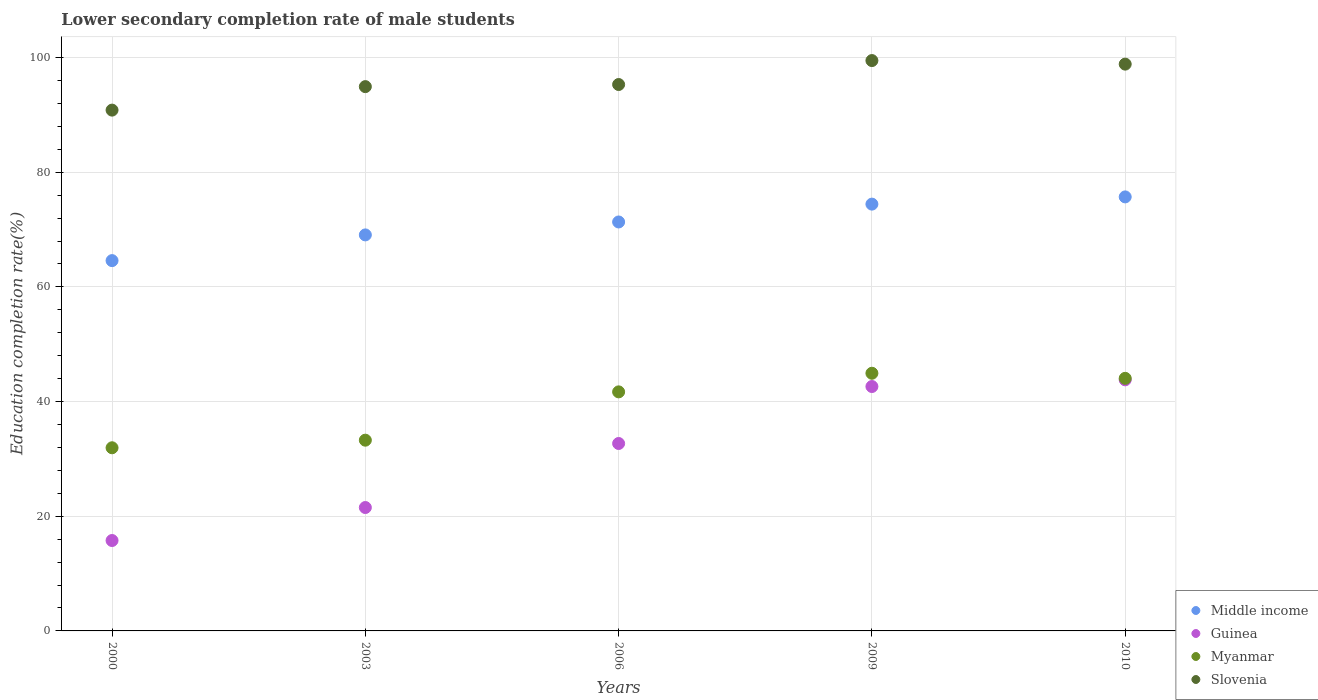What is the lower secondary completion rate of male students in Guinea in 2009?
Give a very brief answer. 42.62. Across all years, what is the maximum lower secondary completion rate of male students in Slovenia?
Offer a very short reply. 99.47. Across all years, what is the minimum lower secondary completion rate of male students in Myanmar?
Your answer should be very brief. 31.94. What is the total lower secondary completion rate of male students in Slovenia in the graph?
Give a very brief answer. 479.35. What is the difference between the lower secondary completion rate of male students in Middle income in 2003 and that in 2010?
Your answer should be very brief. -6.63. What is the difference between the lower secondary completion rate of male students in Slovenia in 2003 and the lower secondary completion rate of male students in Myanmar in 2000?
Your answer should be compact. 62.98. What is the average lower secondary completion rate of male students in Middle income per year?
Ensure brevity in your answer.  71.02. In the year 2000, what is the difference between the lower secondary completion rate of male students in Guinea and lower secondary completion rate of male students in Middle income?
Give a very brief answer. -48.81. In how many years, is the lower secondary completion rate of male students in Guinea greater than 44 %?
Your answer should be compact. 0. What is the ratio of the lower secondary completion rate of male students in Middle income in 2003 to that in 2009?
Ensure brevity in your answer.  0.93. Is the difference between the lower secondary completion rate of male students in Guinea in 2006 and 2009 greater than the difference between the lower secondary completion rate of male students in Middle income in 2006 and 2009?
Your response must be concise. No. What is the difference between the highest and the second highest lower secondary completion rate of male students in Middle income?
Provide a succinct answer. 1.26. What is the difference between the highest and the lowest lower secondary completion rate of male students in Middle income?
Your response must be concise. 11.11. In how many years, is the lower secondary completion rate of male students in Middle income greater than the average lower secondary completion rate of male students in Middle income taken over all years?
Provide a succinct answer. 3. Is the lower secondary completion rate of male students in Guinea strictly greater than the lower secondary completion rate of male students in Myanmar over the years?
Offer a very short reply. No. What is the difference between two consecutive major ticks on the Y-axis?
Keep it short and to the point. 20. Are the values on the major ticks of Y-axis written in scientific E-notation?
Make the answer very short. No. Where does the legend appear in the graph?
Ensure brevity in your answer.  Bottom right. How many legend labels are there?
Provide a short and direct response. 4. What is the title of the graph?
Your answer should be compact. Lower secondary completion rate of male students. Does "Isle of Man" appear as one of the legend labels in the graph?
Your response must be concise. No. What is the label or title of the Y-axis?
Provide a succinct answer. Education completion rate(%). What is the Education completion rate(%) of Middle income in 2000?
Keep it short and to the point. 64.58. What is the Education completion rate(%) of Guinea in 2000?
Your answer should be compact. 15.77. What is the Education completion rate(%) in Myanmar in 2000?
Keep it short and to the point. 31.94. What is the Education completion rate(%) of Slovenia in 2000?
Provide a succinct answer. 90.83. What is the Education completion rate(%) in Middle income in 2003?
Ensure brevity in your answer.  69.06. What is the Education completion rate(%) in Guinea in 2003?
Offer a very short reply. 21.52. What is the Education completion rate(%) of Myanmar in 2003?
Offer a very short reply. 33.26. What is the Education completion rate(%) of Slovenia in 2003?
Provide a succinct answer. 94.92. What is the Education completion rate(%) of Middle income in 2006?
Keep it short and to the point. 71.32. What is the Education completion rate(%) of Guinea in 2006?
Give a very brief answer. 32.69. What is the Education completion rate(%) in Myanmar in 2006?
Offer a terse response. 41.69. What is the Education completion rate(%) in Slovenia in 2006?
Offer a terse response. 95.29. What is the Education completion rate(%) in Middle income in 2009?
Your response must be concise. 74.43. What is the Education completion rate(%) of Guinea in 2009?
Your answer should be compact. 42.62. What is the Education completion rate(%) of Myanmar in 2009?
Offer a terse response. 44.94. What is the Education completion rate(%) in Slovenia in 2009?
Your answer should be very brief. 99.47. What is the Education completion rate(%) of Middle income in 2010?
Your response must be concise. 75.69. What is the Education completion rate(%) in Guinea in 2010?
Offer a very short reply. 43.79. What is the Education completion rate(%) of Myanmar in 2010?
Keep it short and to the point. 44.05. What is the Education completion rate(%) of Slovenia in 2010?
Your response must be concise. 98.85. Across all years, what is the maximum Education completion rate(%) of Middle income?
Give a very brief answer. 75.69. Across all years, what is the maximum Education completion rate(%) in Guinea?
Your response must be concise. 43.79. Across all years, what is the maximum Education completion rate(%) of Myanmar?
Ensure brevity in your answer.  44.94. Across all years, what is the maximum Education completion rate(%) of Slovenia?
Your answer should be very brief. 99.47. Across all years, what is the minimum Education completion rate(%) of Middle income?
Offer a terse response. 64.58. Across all years, what is the minimum Education completion rate(%) in Guinea?
Keep it short and to the point. 15.77. Across all years, what is the minimum Education completion rate(%) in Myanmar?
Provide a succinct answer. 31.94. Across all years, what is the minimum Education completion rate(%) of Slovenia?
Your response must be concise. 90.83. What is the total Education completion rate(%) of Middle income in the graph?
Ensure brevity in your answer.  355.09. What is the total Education completion rate(%) in Guinea in the graph?
Your answer should be compact. 156.38. What is the total Education completion rate(%) in Myanmar in the graph?
Provide a succinct answer. 195.88. What is the total Education completion rate(%) in Slovenia in the graph?
Offer a terse response. 479.35. What is the difference between the Education completion rate(%) of Middle income in 2000 and that in 2003?
Provide a succinct answer. -4.48. What is the difference between the Education completion rate(%) in Guinea in 2000 and that in 2003?
Ensure brevity in your answer.  -5.75. What is the difference between the Education completion rate(%) of Myanmar in 2000 and that in 2003?
Make the answer very short. -1.32. What is the difference between the Education completion rate(%) of Slovenia in 2000 and that in 2003?
Your answer should be very brief. -4.1. What is the difference between the Education completion rate(%) in Middle income in 2000 and that in 2006?
Ensure brevity in your answer.  -6.74. What is the difference between the Education completion rate(%) in Guinea in 2000 and that in 2006?
Your answer should be very brief. -16.92. What is the difference between the Education completion rate(%) in Myanmar in 2000 and that in 2006?
Give a very brief answer. -9.75. What is the difference between the Education completion rate(%) of Slovenia in 2000 and that in 2006?
Your response must be concise. -4.46. What is the difference between the Education completion rate(%) in Middle income in 2000 and that in 2009?
Provide a short and direct response. -9.85. What is the difference between the Education completion rate(%) of Guinea in 2000 and that in 2009?
Your answer should be compact. -26.86. What is the difference between the Education completion rate(%) of Myanmar in 2000 and that in 2009?
Make the answer very short. -13. What is the difference between the Education completion rate(%) in Slovenia in 2000 and that in 2009?
Provide a short and direct response. -8.64. What is the difference between the Education completion rate(%) in Middle income in 2000 and that in 2010?
Provide a succinct answer. -11.11. What is the difference between the Education completion rate(%) in Guinea in 2000 and that in 2010?
Offer a terse response. -28.02. What is the difference between the Education completion rate(%) in Myanmar in 2000 and that in 2010?
Keep it short and to the point. -12.11. What is the difference between the Education completion rate(%) in Slovenia in 2000 and that in 2010?
Make the answer very short. -8.02. What is the difference between the Education completion rate(%) in Middle income in 2003 and that in 2006?
Provide a succinct answer. -2.26. What is the difference between the Education completion rate(%) in Guinea in 2003 and that in 2006?
Provide a short and direct response. -11.17. What is the difference between the Education completion rate(%) in Myanmar in 2003 and that in 2006?
Your response must be concise. -8.43. What is the difference between the Education completion rate(%) of Slovenia in 2003 and that in 2006?
Keep it short and to the point. -0.37. What is the difference between the Education completion rate(%) of Middle income in 2003 and that in 2009?
Offer a very short reply. -5.37. What is the difference between the Education completion rate(%) of Guinea in 2003 and that in 2009?
Ensure brevity in your answer.  -21.1. What is the difference between the Education completion rate(%) in Myanmar in 2003 and that in 2009?
Ensure brevity in your answer.  -11.67. What is the difference between the Education completion rate(%) of Slovenia in 2003 and that in 2009?
Provide a short and direct response. -4.54. What is the difference between the Education completion rate(%) in Middle income in 2003 and that in 2010?
Offer a terse response. -6.63. What is the difference between the Education completion rate(%) of Guinea in 2003 and that in 2010?
Give a very brief answer. -22.27. What is the difference between the Education completion rate(%) of Myanmar in 2003 and that in 2010?
Your answer should be very brief. -10.79. What is the difference between the Education completion rate(%) of Slovenia in 2003 and that in 2010?
Provide a short and direct response. -3.92. What is the difference between the Education completion rate(%) of Middle income in 2006 and that in 2009?
Your answer should be compact. -3.11. What is the difference between the Education completion rate(%) of Guinea in 2006 and that in 2009?
Your answer should be very brief. -9.94. What is the difference between the Education completion rate(%) in Myanmar in 2006 and that in 2009?
Provide a succinct answer. -3.25. What is the difference between the Education completion rate(%) of Slovenia in 2006 and that in 2009?
Your answer should be very brief. -4.18. What is the difference between the Education completion rate(%) in Middle income in 2006 and that in 2010?
Offer a very short reply. -4.37. What is the difference between the Education completion rate(%) of Guinea in 2006 and that in 2010?
Ensure brevity in your answer.  -11.1. What is the difference between the Education completion rate(%) of Myanmar in 2006 and that in 2010?
Your response must be concise. -2.36. What is the difference between the Education completion rate(%) in Slovenia in 2006 and that in 2010?
Give a very brief answer. -3.56. What is the difference between the Education completion rate(%) in Middle income in 2009 and that in 2010?
Offer a very short reply. -1.26. What is the difference between the Education completion rate(%) in Guinea in 2009 and that in 2010?
Your answer should be very brief. -1.17. What is the difference between the Education completion rate(%) of Myanmar in 2009 and that in 2010?
Provide a succinct answer. 0.89. What is the difference between the Education completion rate(%) of Slovenia in 2009 and that in 2010?
Your response must be concise. 0.62. What is the difference between the Education completion rate(%) of Middle income in 2000 and the Education completion rate(%) of Guinea in 2003?
Ensure brevity in your answer.  43.06. What is the difference between the Education completion rate(%) of Middle income in 2000 and the Education completion rate(%) of Myanmar in 2003?
Your answer should be compact. 31.32. What is the difference between the Education completion rate(%) in Middle income in 2000 and the Education completion rate(%) in Slovenia in 2003?
Offer a very short reply. -30.34. What is the difference between the Education completion rate(%) of Guinea in 2000 and the Education completion rate(%) of Myanmar in 2003?
Your response must be concise. -17.5. What is the difference between the Education completion rate(%) of Guinea in 2000 and the Education completion rate(%) of Slovenia in 2003?
Offer a very short reply. -79.16. What is the difference between the Education completion rate(%) in Myanmar in 2000 and the Education completion rate(%) in Slovenia in 2003?
Your response must be concise. -62.98. What is the difference between the Education completion rate(%) in Middle income in 2000 and the Education completion rate(%) in Guinea in 2006?
Your response must be concise. 31.89. What is the difference between the Education completion rate(%) in Middle income in 2000 and the Education completion rate(%) in Myanmar in 2006?
Your answer should be very brief. 22.89. What is the difference between the Education completion rate(%) of Middle income in 2000 and the Education completion rate(%) of Slovenia in 2006?
Your response must be concise. -30.71. What is the difference between the Education completion rate(%) in Guinea in 2000 and the Education completion rate(%) in Myanmar in 2006?
Make the answer very short. -25.92. What is the difference between the Education completion rate(%) of Guinea in 2000 and the Education completion rate(%) of Slovenia in 2006?
Provide a short and direct response. -79.52. What is the difference between the Education completion rate(%) of Myanmar in 2000 and the Education completion rate(%) of Slovenia in 2006?
Keep it short and to the point. -63.35. What is the difference between the Education completion rate(%) of Middle income in 2000 and the Education completion rate(%) of Guinea in 2009?
Your answer should be very brief. 21.96. What is the difference between the Education completion rate(%) in Middle income in 2000 and the Education completion rate(%) in Myanmar in 2009?
Your answer should be compact. 19.64. What is the difference between the Education completion rate(%) in Middle income in 2000 and the Education completion rate(%) in Slovenia in 2009?
Provide a succinct answer. -34.89. What is the difference between the Education completion rate(%) of Guinea in 2000 and the Education completion rate(%) of Myanmar in 2009?
Provide a short and direct response. -29.17. What is the difference between the Education completion rate(%) in Guinea in 2000 and the Education completion rate(%) in Slovenia in 2009?
Your answer should be very brief. -83.7. What is the difference between the Education completion rate(%) of Myanmar in 2000 and the Education completion rate(%) of Slovenia in 2009?
Provide a succinct answer. -67.53. What is the difference between the Education completion rate(%) of Middle income in 2000 and the Education completion rate(%) of Guinea in 2010?
Make the answer very short. 20.79. What is the difference between the Education completion rate(%) of Middle income in 2000 and the Education completion rate(%) of Myanmar in 2010?
Provide a succinct answer. 20.53. What is the difference between the Education completion rate(%) of Middle income in 2000 and the Education completion rate(%) of Slovenia in 2010?
Offer a very short reply. -34.27. What is the difference between the Education completion rate(%) in Guinea in 2000 and the Education completion rate(%) in Myanmar in 2010?
Provide a short and direct response. -28.28. What is the difference between the Education completion rate(%) in Guinea in 2000 and the Education completion rate(%) in Slovenia in 2010?
Give a very brief answer. -83.08. What is the difference between the Education completion rate(%) in Myanmar in 2000 and the Education completion rate(%) in Slovenia in 2010?
Your answer should be very brief. -66.91. What is the difference between the Education completion rate(%) in Middle income in 2003 and the Education completion rate(%) in Guinea in 2006?
Ensure brevity in your answer.  36.38. What is the difference between the Education completion rate(%) in Middle income in 2003 and the Education completion rate(%) in Myanmar in 2006?
Your response must be concise. 27.37. What is the difference between the Education completion rate(%) in Middle income in 2003 and the Education completion rate(%) in Slovenia in 2006?
Ensure brevity in your answer.  -26.23. What is the difference between the Education completion rate(%) of Guinea in 2003 and the Education completion rate(%) of Myanmar in 2006?
Offer a terse response. -20.17. What is the difference between the Education completion rate(%) of Guinea in 2003 and the Education completion rate(%) of Slovenia in 2006?
Your answer should be compact. -73.77. What is the difference between the Education completion rate(%) in Myanmar in 2003 and the Education completion rate(%) in Slovenia in 2006?
Give a very brief answer. -62.03. What is the difference between the Education completion rate(%) in Middle income in 2003 and the Education completion rate(%) in Guinea in 2009?
Offer a terse response. 26.44. What is the difference between the Education completion rate(%) of Middle income in 2003 and the Education completion rate(%) of Myanmar in 2009?
Keep it short and to the point. 24.13. What is the difference between the Education completion rate(%) in Middle income in 2003 and the Education completion rate(%) in Slovenia in 2009?
Provide a short and direct response. -30.4. What is the difference between the Education completion rate(%) of Guinea in 2003 and the Education completion rate(%) of Myanmar in 2009?
Provide a short and direct response. -23.42. What is the difference between the Education completion rate(%) in Guinea in 2003 and the Education completion rate(%) in Slovenia in 2009?
Keep it short and to the point. -77.95. What is the difference between the Education completion rate(%) in Myanmar in 2003 and the Education completion rate(%) in Slovenia in 2009?
Your answer should be very brief. -66.2. What is the difference between the Education completion rate(%) in Middle income in 2003 and the Education completion rate(%) in Guinea in 2010?
Ensure brevity in your answer.  25.28. What is the difference between the Education completion rate(%) of Middle income in 2003 and the Education completion rate(%) of Myanmar in 2010?
Make the answer very short. 25.01. What is the difference between the Education completion rate(%) of Middle income in 2003 and the Education completion rate(%) of Slovenia in 2010?
Offer a terse response. -29.78. What is the difference between the Education completion rate(%) in Guinea in 2003 and the Education completion rate(%) in Myanmar in 2010?
Your answer should be compact. -22.53. What is the difference between the Education completion rate(%) in Guinea in 2003 and the Education completion rate(%) in Slovenia in 2010?
Offer a very short reply. -77.33. What is the difference between the Education completion rate(%) of Myanmar in 2003 and the Education completion rate(%) of Slovenia in 2010?
Your answer should be compact. -65.58. What is the difference between the Education completion rate(%) in Middle income in 2006 and the Education completion rate(%) in Guinea in 2009?
Keep it short and to the point. 28.7. What is the difference between the Education completion rate(%) in Middle income in 2006 and the Education completion rate(%) in Myanmar in 2009?
Keep it short and to the point. 26.38. What is the difference between the Education completion rate(%) in Middle income in 2006 and the Education completion rate(%) in Slovenia in 2009?
Your answer should be compact. -28.15. What is the difference between the Education completion rate(%) of Guinea in 2006 and the Education completion rate(%) of Myanmar in 2009?
Your answer should be very brief. -12.25. What is the difference between the Education completion rate(%) of Guinea in 2006 and the Education completion rate(%) of Slovenia in 2009?
Offer a very short reply. -66.78. What is the difference between the Education completion rate(%) in Myanmar in 2006 and the Education completion rate(%) in Slovenia in 2009?
Offer a very short reply. -57.78. What is the difference between the Education completion rate(%) of Middle income in 2006 and the Education completion rate(%) of Guinea in 2010?
Provide a succinct answer. 27.53. What is the difference between the Education completion rate(%) of Middle income in 2006 and the Education completion rate(%) of Myanmar in 2010?
Give a very brief answer. 27.27. What is the difference between the Education completion rate(%) of Middle income in 2006 and the Education completion rate(%) of Slovenia in 2010?
Provide a succinct answer. -27.53. What is the difference between the Education completion rate(%) in Guinea in 2006 and the Education completion rate(%) in Myanmar in 2010?
Your answer should be compact. -11.36. What is the difference between the Education completion rate(%) in Guinea in 2006 and the Education completion rate(%) in Slovenia in 2010?
Provide a succinct answer. -66.16. What is the difference between the Education completion rate(%) of Myanmar in 2006 and the Education completion rate(%) of Slovenia in 2010?
Your answer should be compact. -57.16. What is the difference between the Education completion rate(%) of Middle income in 2009 and the Education completion rate(%) of Guinea in 2010?
Offer a terse response. 30.64. What is the difference between the Education completion rate(%) in Middle income in 2009 and the Education completion rate(%) in Myanmar in 2010?
Offer a terse response. 30.38. What is the difference between the Education completion rate(%) in Middle income in 2009 and the Education completion rate(%) in Slovenia in 2010?
Provide a succinct answer. -24.41. What is the difference between the Education completion rate(%) in Guinea in 2009 and the Education completion rate(%) in Myanmar in 2010?
Your answer should be very brief. -1.43. What is the difference between the Education completion rate(%) in Guinea in 2009 and the Education completion rate(%) in Slovenia in 2010?
Keep it short and to the point. -56.22. What is the difference between the Education completion rate(%) in Myanmar in 2009 and the Education completion rate(%) in Slovenia in 2010?
Give a very brief answer. -53.91. What is the average Education completion rate(%) in Middle income per year?
Provide a succinct answer. 71.02. What is the average Education completion rate(%) in Guinea per year?
Give a very brief answer. 31.28. What is the average Education completion rate(%) in Myanmar per year?
Offer a very short reply. 39.18. What is the average Education completion rate(%) in Slovenia per year?
Your response must be concise. 95.87. In the year 2000, what is the difference between the Education completion rate(%) of Middle income and Education completion rate(%) of Guinea?
Make the answer very short. 48.81. In the year 2000, what is the difference between the Education completion rate(%) of Middle income and Education completion rate(%) of Myanmar?
Your answer should be compact. 32.64. In the year 2000, what is the difference between the Education completion rate(%) in Middle income and Education completion rate(%) in Slovenia?
Ensure brevity in your answer.  -26.25. In the year 2000, what is the difference between the Education completion rate(%) in Guinea and Education completion rate(%) in Myanmar?
Give a very brief answer. -16.17. In the year 2000, what is the difference between the Education completion rate(%) of Guinea and Education completion rate(%) of Slovenia?
Keep it short and to the point. -75.06. In the year 2000, what is the difference between the Education completion rate(%) of Myanmar and Education completion rate(%) of Slovenia?
Your answer should be very brief. -58.89. In the year 2003, what is the difference between the Education completion rate(%) in Middle income and Education completion rate(%) in Guinea?
Your response must be concise. 47.54. In the year 2003, what is the difference between the Education completion rate(%) in Middle income and Education completion rate(%) in Myanmar?
Give a very brief answer. 35.8. In the year 2003, what is the difference between the Education completion rate(%) of Middle income and Education completion rate(%) of Slovenia?
Your answer should be compact. -25.86. In the year 2003, what is the difference between the Education completion rate(%) in Guinea and Education completion rate(%) in Myanmar?
Your answer should be compact. -11.74. In the year 2003, what is the difference between the Education completion rate(%) of Guinea and Education completion rate(%) of Slovenia?
Ensure brevity in your answer.  -73.4. In the year 2003, what is the difference between the Education completion rate(%) of Myanmar and Education completion rate(%) of Slovenia?
Offer a terse response. -61.66. In the year 2006, what is the difference between the Education completion rate(%) in Middle income and Education completion rate(%) in Guinea?
Provide a short and direct response. 38.63. In the year 2006, what is the difference between the Education completion rate(%) in Middle income and Education completion rate(%) in Myanmar?
Give a very brief answer. 29.63. In the year 2006, what is the difference between the Education completion rate(%) in Middle income and Education completion rate(%) in Slovenia?
Ensure brevity in your answer.  -23.97. In the year 2006, what is the difference between the Education completion rate(%) in Guinea and Education completion rate(%) in Myanmar?
Your answer should be very brief. -9. In the year 2006, what is the difference between the Education completion rate(%) of Guinea and Education completion rate(%) of Slovenia?
Your response must be concise. -62.6. In the year 2006, what is the difference between the Education completion rate(%) of Myanmar and Education completion rate(%) of Slovenia?
Keep it short and to the point. -53.6. In the year 2009, what is the difference between the Education completion rate(%) in Middle income and Education completion rate(%) in Guinea?
Provide a short and direct response. 31.81. In the year 2009, what is the difference between the Education completion rate(%) in Middle income and Education completion rate(%) in Myanmar?
Your answer should be very brief. 29.5. In the year 2009, what is the difference between the Education completion rate(%) in Middle income and Education completion rate(%) in Slovenia?
Ensure brevity in your answer.  -25.04. In the year 2009, what is the difference between the Education completion rate(%) in Guinea and Education completion rate(%) in Myanmar?
Make the answer very short. -2.31. In the year 2009, what is the difference between the Education completion rate(%) of Guinea and Education completion rate(%) of Slovenia?
Give a very brief answer. -56.84. In the year 2009, what is the difference between the Education completion rate(%) of Myanmar and Education completion rate(%) of Slovenia?
Your response must be concise. -54.53. In the year 2010, what is the difference between the Education completion rate(%) of Middle income and Education completion rate(%) of Guinea?
Keep it short and to the point. 31.9. In the year 2010, what is the difference between the Education completion rate(%) of Middle income and Education completion rate(%) of Myanmar?
Provide a succinct answer. 31.64. In the year 2010, what is the difference between the Education completion rate(%) in Middle income and Education completion rate(%) in Slovenia?
Your answer should be compact. -23.15. In the year 2010, what is the difference between the Education completion rate(%) in Guinea and Education completion rate(%) in Myanmar?
Your answer should be compact. -0.26. In the year 2010, what is the difference between the Education completion rate(%) in Guinea and Education completion rate(%) in Slovenia?
Your response must be concise. -55.06. In the year 2010, what is the difference between the Education completion rate(%) in Myanmar and Education completion rate(%) in Slovenia?
Make the answer very short. -54.8. What is the ratio of the Education completion rate(%) of Middle income in 2000 to that in 2003?
Your answer should be compact. 0.94. What is the ratio of the Education completion rate(%) of Guinea in 2000 to that in 2003?
Your response must be concise. 0.73. What is the ratio of the Education completion rate(%) in Myanmar in 2000 to that in 2003?
Make the answer very short. 0.96. What is the ratio of the Education completion rate(%) in Slovenia in 2000 to that in 2003?
Your answer should be very brief. 0.96. What is the ratio of the Education completion rate(%) in Middle income in 2000 to that in 2006?
Provide a succinct answer. 0.91. What is the ratio of the Education completion rate(%) in Guinea in 2000 to that in 2006?
Your answer should be compact. 0.48. What is the ratio of the Education completion rate(%) in Myanmar in 2000 to that in 2006?
Give a very brief answer. 0.77. What is the ratio of the Education completion rate(%) in Slovenia in 2000 to that in 2006?
Offer a terse response. 0.95. What is the ratio of the Education completion rate(%) in Middle income in 2000 to that in 2009?
Your answer should be compact. 0.87. What is the ratio of the Education completion rate(%) in Guinea in 2000 to that in 2009?
Offer a very short reply. 0.37. What is the ratio of the Education completion rate(%) in Myanmar in 2000 to that in 2009?
Provide a short and direct response. 0.71. What is the ratio of the Education completion rate(%) in Slovenia in 2000 to that in 2009?
Give a very brief answer. 0.91. What is the ratio of the Education completion rate(%) in Middle income in 2000 to that in 2010?
Provide a succinct answer. 0.85. What is the ratio of the Education completion rate(%) in Guinea in 2000 to that in 2010?
Your answer should be very brief. 0.36. What is the ratio of the Education completion rate(%) in Myanmar in 2000 to that in 2010?
Your answer should be very brief. 0.73. What is the ratio of the Education completion rate(%) of Slovenia in 2000 to that in 2010?
Give a very brief answer. 0.92. What is the ratio of the Education completion rate(%) in Middle income in 2003 to that in 2006?
Give a very brief answer. 0.97. What is the ratio of the Education completion rate(%) of Guinea in 2003 to that in 2006?
Your response must be concise. 0.66. What is the ratio of the Education completion rate(%) in Myanmar in 2003 to that in 2006?
Provide a short and direct response. 0.8. What is the ratio of the Education completion rate(%) in Slovenia in 2003 to that in 2006?
Your answer should be very brief. 1. What is the ratio of the Education completion rate(%) of Middle income in 2003 to that in 2009?
Your answer should be very brief. 0.93. What is the ratio of the Education completion rate(%) of Guinea in 2003 to that in 2009?
Ensure brevity in your answer.  0.5. What is the ratio of the Education completion rate(%) of Myanmar in 2003 to that in 2009?
Ensure brevity in your answer.  0.74. What is the ratio of the Education completion rate(%) of Slovenia in 2003 to that in 2009?
Keep it short and to the point. 0.95. What is the ratio of the Education completion rate(%) of Middle income in 2003 to that in 2010?
Offer a terse response. 0.91. What is the ratio of the Education completion rate(%) in Guinea in 2003 to that in 2010?
Your response must be concise. 0.49. What is the ratio of the Education completion rate(%) in Myanmar in 2003 to that in 2010?
Provide a succinct answer. 0.76. What is the ratio of the Education completion rate(%) of Slovenia in 2003 to that in 2010?
Offer a terse response. 0.96. What is the ratio of the Education completion rate(%) of Middle income in 2006 to that in 2009?
Keep it short and to the point. 0.96. What is the ratio of the Education completion rate(%) of Guinea in 2006 to that in 2009?
Make the answer very short. 0.77. What is the ratio of the Education completion rate(%) of Myanmar in 2006 to that in 2009?
Provide a short and direct response. 0.93. What is the ratio of the Education completion rate(%) in Slovenia in 2006 to that in 2009?
Ensure brevity in your answer.  0.96. What is the ratio of the Education completion rate(%) in Middle income in 2006 to that in 2010?
Your response must be concise. 0.94. What is the ratio of the Education completion rate(%) in Guinea in 2006 to that in 2010?
Your answer should be very brief. 0.75. What is the ratio of the Education completion rate(%) of Myanmar in 2006 to that in 2010?
Offer a very short reply. 0.95. What is the ratio of the Education completion rate(%) of Slovenia in 2006 to that in 2010?
Ensure brevity in your answer.  0.96. What is the ratio of the Education completion rate(%) in Middle income in 2009 to that in 2010?
Make the answer very short. 0.98. What is the ratio of the Education completion rate(%) in Guinea in 2009 to that in 2010?
Offer a terse response. 0.97. What is the ratio of the Education completion rate(%) in Myanmar in 2009 to that in 2010?
Your answer should be compact. 1.02. What is the ratio of the Education completion rate(%) of Slovenia in 2009 to that in 2010?
Provide a succinct answer. 1.01. What is the difference between the highest and the second highest Education completion rate(%) of Middle income?
Ensure brevity in your answer.  1.26. What is the difference between the highest and the second highest Education completion rate(%) in Guinea?
Your answer should be very brief. 1.17. What is the difference between the highest and the second highest Education completion rate(%) of Myanmar?
Keep it short and to the point. 0.89. What is the difference between the highest and the second highest Education completion rate(%) in Slovenia?
Your answer should be compact. 0.62. What is the difference between the highest and the lowest Education completion rate(%) in Middle income?
Offer a terse response. 11.11. What is the difference between the highest and the lowest Education completion rate(%) in Guinea?
Provide a short and direct response. 28.02. What is the difference between the highest and the lowest Education completion rate(%) in Myanmar?
Your response must be concise. 13. What is the difference between the highest and the lowest Education completion rate(%) of Slovenia?
Offer a terse response. 8.64. 